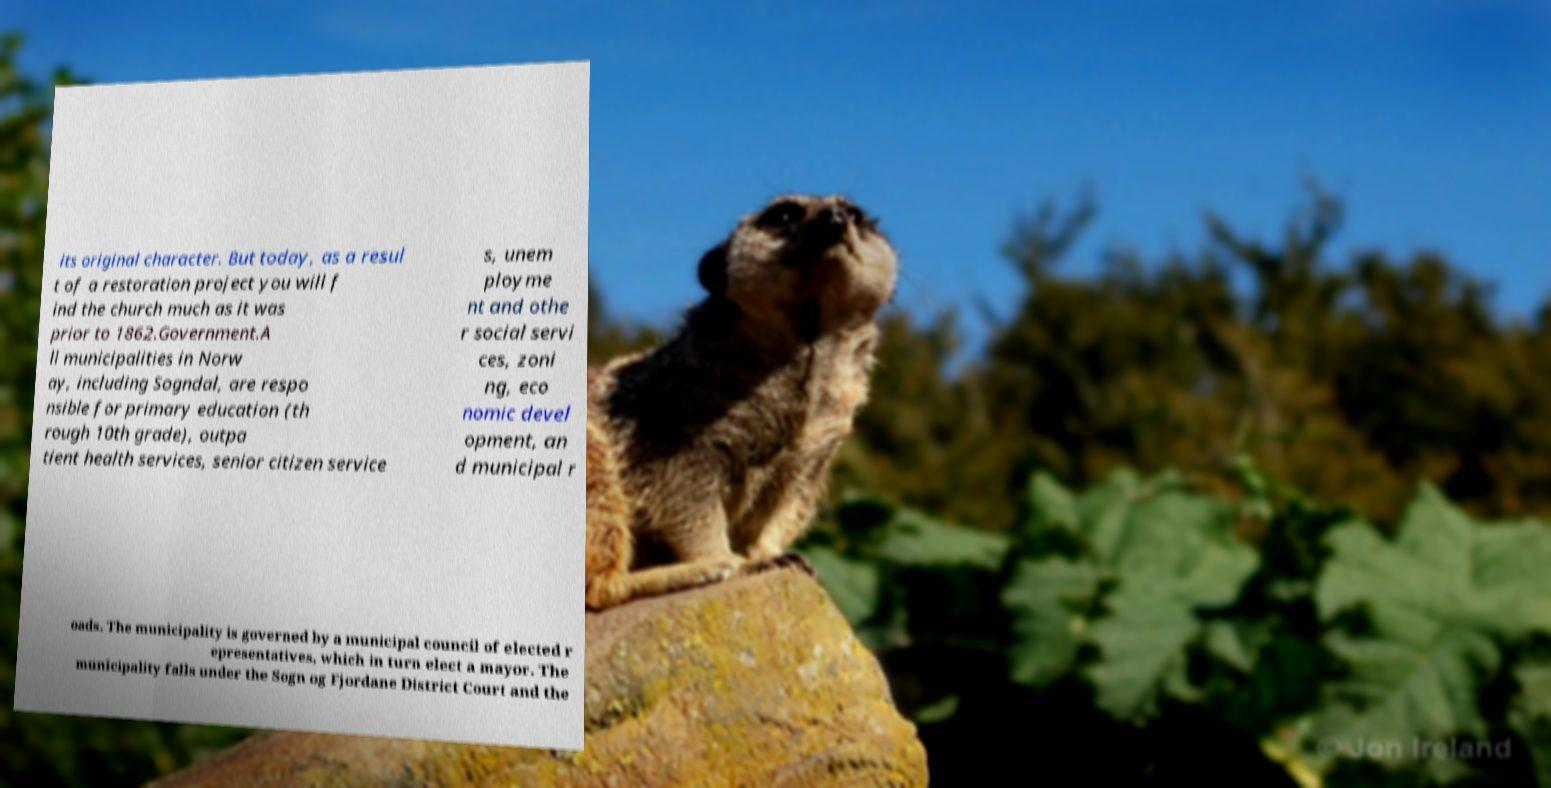Please identify and transcribe the text found in this image. its original character. But today, as a resul t of a restoration project you will f ind the church much as it was prior to 1862.Government.A ll municipalities in Norw ay, including Sogndal, are respo nsible for primary education (th rough 10th grade), outpa tient health services, senior citizen service s, unem ployme nt and othe r social servi ces, zoni ng, eco nomic devel opment, an d municipal r oads. The municipality is governed by a municipal council of elected r epresentatives, which in turn elect a mayor. The municipality falls under the Sogn og Fjordane District Court and the 